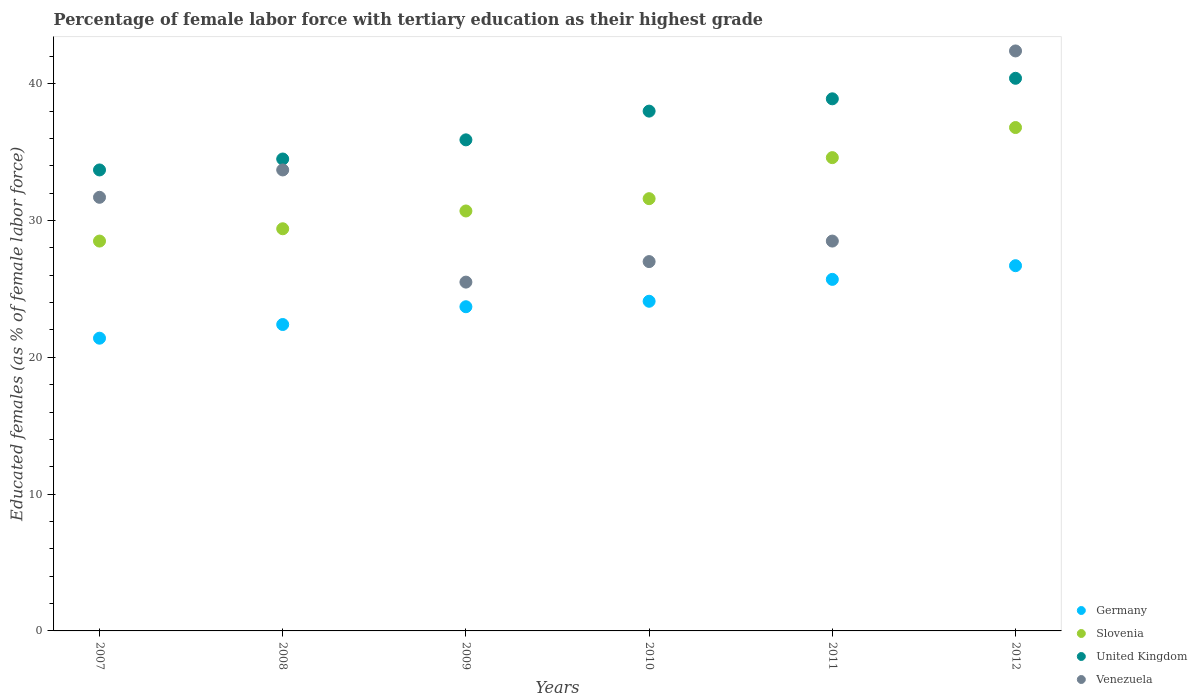Across all years, what is the maximum percentage of female labor force with tertiary education in United Kingdom?
Provide a short and direct response. 40.4. Across all years, what is the minimum percentage of female labor force with tertiary education in Germany?
Offer a terse response. 21.4. In which year was the percentage of female labor force with tertiary education in Germany maximum?
Give a very brief answer. 2012. In which year was the percentage of female labor force with tertiary education in Germany minimum?
Keep it short and to the point. 2007. What is the total percentage of female labor force with tertiary education in Venezuela in the graph?
Your response must be concise. 188.8. What is the difference between the percentage of female labor force with tertiary education in Venezuela in 2007 and that in 2012?
Give a very brief answer. -10.7. What is the difference between the percentage of female labor force with tertiary education in Germany in 2011 and the percentage of female labor force with tertiary education in Venezuela in 2010?
Give a very brief answer. -1.3. What is the average percentage of female labor force with tertiary education in United Kingdom per year?
Provide a short and direct response. 36.9. In how many years, is the percentage of female labor force with tertiary education in Slovenia greater than 10 %?
Your answer should be compact. 6. What is the ratio of the percentage of female labor force with tertiary education in Slovenia in 2007 to that in 2008?
Keep it short and to the point. 0.97. What is the difference between the highest and the lowest percentage of female labor force with tertiary education in Slovenia?
Your response must be concise. 8.3. Is it the case that in every year, the sum of the percentage of female labor force with tertiary education in United Kingdom and percentage of female labor force with tertiary education in Slovenia  is greater than the sum of percentage of female labor force with tertiary education in Venezuela and percentage of female labor force with tertiary education in Germany?
Provide a short and direct response. Yes. Is it the case that in every year, the sum of the percentage of female labor force with tertiary education in Germany and percentage of female labor force with tertiary education in Venezuela  is greater than the percentage of female labor force with tertiary education in United Kingdom?
Give a very brief answer. Yes. Does the percentage of female labor force with tertiary education in Germany monotonically increase over the years?
Your response must be concise. Yes. Is the percentage of female labor force with tertiary education in Venezuela strictly less than the percentage of female labor force with tertiary education in United Kingdom over the years?
Your response must be concise. No. How many dotlines are there?
Provide a succinct answer. 4. How many years are there in the graph?
Ensure brevity in your answer.  6. Does the graph contain any zero values?
Give a very brief answer. No. How many legend labels are there?
Make the answer very short. 4. How are the legend labels stacked?
Make the answer very short. Vertical. What is the title of the graph?
Your answer should be very brief. Percentage of female labor force with tertiary education as their highest grade. What is the label or title of the Y-axis?
Ensure brevity in your answer.  Educated females (as % of female labor force). What is the Educated females (as % of female labor force) of Germany in 2007?
Provide a succinct answer. 21.4. What is the Educated females (as % of female labor force) of United Kingdom in 2007?
Keep it short and to the point. 33.7. What is the Educated females (as % of female labor force) of Venezuela in 2007?
Ensure brevity in your answer.  31.7. What is the Educated females (as % of female labor force) in Germany in 2008?
Offer a terse response. 22.4. What is the Educated females (as % of female labor force) of Slovenia in 2008?
Keep it short and to the point. 29.4. What is the Educated females (as % of female labor force) in United Kingdom in 2008?
Keep it short and to the point. 34.5. What is the Educated females (as % of female labor force) of Venezuela in 2008?
Give a very brief answer. 33.7. What is the Educated females (as % of female labor force) of Germany in 2009?
Offer a terse response. 23.7. What is the Educated females (as % of female labor force) of Slovenia in 2009?
Provide a short and direct response. 30.7. What is the Educated females (as % of female labor force) in United Kingdom in 2009?
Ensure brevity in your answer.  35.9. What is the Educated females (as % of female labor force) in Venezuela in 2009?
Give a very brief answer. 25.5. What is the Educated females (as % of female labor force) of Germany in 2010?
Keep it short and to the point. 24.1. What is the Educated females (as % of female labor force) in Slovenia in 2010?
Keep it short and to the point. 31.6. What is the Educated females (as % of female labor force) of Venezuela in 2010?
Your answer should be very brief. 27. What is the Educated females (as % of female labor force) in Germany in 2011?
Provide a short and direct response. 25.7. What is the Educated females (as % of female labor force) in Slovenia in 2011?
Ensure brevity in your answer.  34.6. What is the Educated females (as % of female labor force) in United Kingdom in 2011?
Keep it short and to the point. 38.9. What is the Educated females (as % of female labor force) in Germany in 2012?
Offer a terse response. 26.7. What is the Educated females (as % of female labor force) of Slovenia in 2012?
Offer a very short reply. 36.8. What is the Educated females (as % of female labor force) in United Kingdom in 2012?
Offer a terse response. 40.4. What is the Educated females (as % of female labor force) of Venezuela in 2012?
Your answer should be compact. 42.4. Across all years, what is the maximum Educated females (as % of female labor force) of Germany?
Your response must be concise. 26.7. Across all years, what is the maximum Educated females (as % of female labor force) of Slovenia?
Ensure brevity in your answer.  36.8. Across all years, what is the maximum Educated females (as % of female labor force) in United Kingdom?
Provide a succinct answer. 40.4. Across all years, what is the maximum Educated females (as % of female labor force) in Venezuela?
Your response must be concise. 42.4. Across all years, what is the minimum Educated females (as % of female labor force) in Germany?
Your response must be concise. 21.4. Across all years, what is the minimum Educated females (as % of female labor force) of Slovenia?
Make the answer very short. 28.5. Across all years, what is the minimum Educated females (as % of female labor force) of United Kingdom?
Give a very brief answer. 33.7. What is the total Educated females (as % of female labor force) of Germany in the graph?
Provide a short and direct response. 144. What is the total Educated females (as % of female labor force) in Slovenia in the graph?
Keep it short and to the point. 191.6. What is the total Educated females (as % of female labor force) of United Kingdom in the graph?
Keep it short and to the point. 221.4. What is the total Educated females (as % of female labor force) of Venezuela in the graph?
Your response must be concise. 188.8. What is the difference between the Educated females (as % of female labor force) in Slovenia in 2007 and that in 2008?
Your response must be concise. -0.9. What is the difference between the Educated females (as % of female labor force) of United Kingdom in 2007 and that in 2008?
Ensure brevity in your answer.  -0.8. What is the difference between the Educated females (as % of female labor force) in Germany in 2007 and that in 2009?
Make the answer very short. -2.3. What is the difference between the Educated females (as % of female labor force) in Slovenia in 2007 and that in 2009?
Make the answer very short. -2.2. What is the difference between the Educated females (as % of female labor force) in United Kingdom in 2007 and that in 2009?
Give a very brief answer. -2.2. What is the difference between the Educated females (as % of female labor force) of Venezuela in 2007 and that in 2009?
Make the answer very short. 6.2. What is the difference between the Educated females (as % of female labor force) of Slovenia in 2007 and that in 2010?
Ensure brevity in your answer.  -3.1. What is the difference between the Educated females (as % of female labor force) in Germany in 2007 and that in 2011?
Your answer should be compact. -4.3. What is the difference between the Educated females (as % of female labor force) of Germany in 2007 and that in 2012?
Offer a terse response. -5.3. What is the difference between the Educated females (as % of female labor force) in Venezuela in 2007 and that in 2012?
Your answer should be compact. -10.7. What is the difference between the Educated females (as % of female labor force) in Venezuela in 2008 and that in 2009?
Provide a succinct answer. 8.2. What is the difference between the Educated females (as % of female labor force) in Germany in 2008 and that in 2010?
Your answer should be very brief. -1.7. What is the difference between the Educated females (as % of female labor force) in Slovenia in 2008 and that in 2010?
Your answer should be compact. -2.2. What is the difference between the Educated females (as % of female labor force) of Slovenia in 2008 and that in 2011?
Your answer should be very brief. -5.2. What is the difference between the Educated females (as % of female labor force) of Venezuela in 2008 and that in 2011?
Your answer should be very brief. 5.2. What is the difference between the Educated females (as % of female labor force) of Germany in 2008 and that in 2012?
Your response must be concise. -4.3. What is the difference between the Educated females (as % of female labor force) of Venezuela in 2008 and that in 2012?
Provide a succinct answer. -8.7. What is the difference between the Educated females (as % of female labor force) in Venezuela in 2009 and that in 2011?
Your answer should be compact. -3. What is the difference between the Educated females (as % of female labor force) of Slovenia in 2009 and that in 2012?
Your answer should be compact. -6.1. What is the difference between the Educated females (as % of female labor force) of Venezuela in 2009 and that in 2012?
Ensure brevity in your answer.  -16.9. What is the difference between the Educated females (as % of female labor force) of United Kingdom in 2010 and that in 2011?
Your response must be concise. -0.9. What is the difference between the Educated females (as % of female labor force) of Germany in 2010 and that in 2012?
Ensure brevity in your answer.  -2.6. What is the difference between the Educated females (as % of female labor force) of United Kingdom in 2010 and that in 2012?
Provide a succinct answer. -2.4. What is the difference between the Educated females (as % of female labor force) of Venezuela in 2010 and that in 2012?
Provide a short and direct response. -15.4. What is the difference between the Educated females (as % of female labor force) in United Kingdom in 2011 and that in 2012?
Your answer should be very brief. -1.5. What is the difference between the Educated females (as % of female labor force) in Germany in 2007 and the Educated females (as % of female labor force) in United Kingdom in 2008?
Ensure brevity in your answer.  -13.1. What is the difference between the Educated females (as % of female labor force) of Slovenia in 2007 and the Educated females (as % of female labor force) of United Kingdom in 2008?
Your response must be concise. -6. What is the difference between the Educated females (as % of female labor force) of Germany in 2007 and the Educated females (as % of female labor force) of Venezuela in 2009?
Provide a succinct answer. -4.1. What is the difference between the Educated females (as % of female labor force) of Slovenia in 2007 and the Educated females (as % of female labor force) of United Kingdom in 2009?
Provide a short and direct response. -7.4. What is the difference between the Educated females (as % of female labor force) of Germany in 2007 and the Educated females (as % of female labor force) of Slovenia in 2010?
Ensure brevity in your answer.  -10.2. What is the difference between the Educated females (as % of female labor force) in Germany in 2007 and the Educated females (as % of female labor force) in United Kingdom in 2010?
Make the answer very short. -16.6. What is the difference between the Educated females (as % of female labor force) in Germany in 2007 and the Educated females (as % of female labor force) in Venezuela in 2010?
Provide a succinct answer. -5.6. What is the difference between the Educated females (as % of female labor force) in Slovenia in 2007 and the Educated females (as % of female labor force) in United Kingdom in 2010?
Give a very brief answer. -9.5. What is the difference between the Educated females (as % of female labor force) of Slovenia in 2007 and the Educated females (as % of female labor force) of Venezuela in 2010?
Your response must be concise. 1.5. What is the difference between the Educated females (as % of female labor force) of Germany in 2007 and the Educated females (as % of female labor force) of Slovenia in 2011?
Provide a short and direct response. -13.2. What is the difference between the Educated females (as % of female labor force) in Germany in 2007 and the Educated females (as % of female labor force) in United Kingdom in 2011?
Provide a short and direct response. -17.5. What is the difference between the Educated females (as % of female labor force) of Germany in 2007 and the Educated females (as % of female labor force) of Venezuela in 2011?
Provide a succinct answer. -7.1. What is the difference between the Educated females (as % of female labor force) of United Kingdom in 2007 and the Educated females (as % of female labor force) of Venezuela in 2011?
Give a very brief answer. 5.2. What is the difference between the Educated females (as % of female labor force) of Germany in 2007 and the Educated females (as % of female labor force) of Slovenia in 2012?
Your answer should be very brief. -15.4. What is the difference between the Educated females (as % of female labor force) in Slovenia in 2007 and the Educated females (as % of female labor force) in United Kingdom in 2012?
Keep it short and to the point. -11.9. What is the difference between the Educated females (as % of female labor force) in Slovenia in 2007 and the Educated females (as % of female labor force) in Venezuela in 2012?
Make the answer very short. -13.9. What is the difference between the Educated females (as % of female labor force) in Germany in 2008 and the Educated females (as % of female labor force) in Slovenia in 2009?
Offer a terse response. -8.3. What is the difference between the Educated females (as % of female labor force) in Germany in 2008 and the Educated females (as % of female labor force) in Venezuela in 2009?
Ensure brevity in your answer.  -3.1. What is the difference between the Educated females (as % of female labor force) in Slovenia in 2008 and the Educated females (as % of female labor force) in Venezuela in 2009?
Provide a short and direct response. 3.9. What is the difference between the Educated females (as % of female labor force) in Germany in 2008 and the Educated females (as % of female labor force) in United Kingdom in 2010?
Make the answer very short. -15.6. What is the difference between the Educated females (as % of female labor force) in Slovenia in 2008 and the Educated females (as % of female labor force) in United Kingdom in 2010?
Your response must be concise. -8.6. What is the difference between the Educated females (as % of female labor force) in United Kingdom in 2008 and the Educated females (as % of female labor force) in Venezuela in 2010?
Keep it short and to the point. 7.5. What is the difference between the Educated females (as % of female labor force) of Germany in 2008 and the Educated females (as % of female labor force) of United Kingdom in 2011?
Your answer should be compact. -16.5. What is the difference between the Educated females (as % of female labor force) of Germany in 2008 and the Educated females (as % of female labor force) of Venezuela in 2011?
Offer a very short reply. -6.1. What is the difference between the Educated females (as % of female labor force) of Slovenia in 2008 and the Educated females (as % of female labor force) of United Kingdom in 2011?
Give a very brief answer. -9.5. What is the difference between the Educated females (as % of female labor force) in Slovenia in 2008 and the Educated females (as % of female labor force) in Venezuela in 2011?
Offer a very short reply. 0.9. What is the difference between the Educated females (as % of female labor force) of United Kingdom in 2008 and the Educated females (as % of female labor force) of Venezuela in 2011?
Provide a succinct answer. 6. What is the difference between the Educated females (as % of female labor force) in Germany in 2008 and the Educated females (as % of female labor force) in Slovenia in 2012?
Give a very brief answer. -14.4. What is the difference between the Educated females (as % of female labor force) in Germany in 2008 and the Educated females (as % of female labor force) in Venezuela in 2012?
Give a very brief answer. -20. What is the difference between the Educated females (as % of female labor force) in Slovenia in 2008 and the Educated females (as % of female labor force) in United Kingdom in 2012?
Provide a succinct answer. -11. What is the difference between the Educated females (as % of female labor force) of Slovenia in 2008 and the Educated females (as % of female labor force) of Venezuela in 2012?
Provide a succinct answer. -13. What is the difference between the Educated females (as % of female labor force) of Germany in 2009 and the Educated females (as % of female labor force) of United Kingdom in 2010?
Your answer should be very brief. -14.3. What is the difference between the Educated females (as % of female labor force) of Germany in 2009 and the Educated females (as % of female labor force) of Venezuela in 2010?
Ensure brevity in your answer.  -3.3. What is the difference between the Educated females (as % of female labor force) of Slovenia in 2009 and the Educated females (as % of female labor force) of United Kingdom in 2010?
Make the answer very short. -7.3. What is the difference between the Educated females (as % of female labor force) in United Kingdom in 2009 and the Educated females (as % of female labor force) in Venezuela in 2010?
Your answer should be very brief. 8.9. What is the difference between the Educated females (as % of female labor force) in Germany in 2009 and the Educated females (as % of female labor force) in United Kingdom in 2011?
Provide a short and direct response. -15.2. What is the difference between the Educated females (as % of female labor force) of Germany in 2009 and the Educated females (as % of female labor force) of Venezuela in 2011?
Your answer should be very brief. -4.8. What is the difference between the Educated females (as % of female labor force) in Slovenia in 2009 and the Educated females (as % of female labor force) in United Kingdom in 2011?
Your response must be concise. -8.2. What is the difference between the Educated females (as % of female labor force) in Slovenia in 2009 and the Educated females (as % of female labor force) in Venezuela in 2011?
Ensure brevity in your answer.  2.2. What is the difference between the Educated females (as % of female labor force) of United Kingdom in 2009 and the Educated females (as % of female labor force) of Venezuela in 2011?
Provide a succinct answer. 7.4. What is the difference between the Educated females (as % of female labor force) of Germany in 2009 and the Educated females (as % of female labor force) of Slovenia in 2012?
Your answer should be very brief. -13.1. What is the difference between the Educated females (as % of female labor force) of Germany in 2009 and the Educated females (as % of female labor force) of United Kingdom in 2012?
Offer a terse response. -16.7. What is the difference between the Educated females (as % of female labor force) of Germany in 2009 and the Educated females (as % of female labor force) of Venezuela in 2012?
Ensure brevity in your answer.  -18.7. What is the difference between the Educated females (as % of female labor force) in United Kingdom in 2009 and the Educated females (as % of female labor force) in Venezuela in 2012?
Give a very brief answer. -6.5. What is the difference between the Educated females (as % of female labor force) of Germany in 2010 and the Educated females (as % of female labor force) of United Kingdom in 2011?
Provide a short and direct response. -14.8. What is the difference between the Educated females (as % of female labor force) in Germany in 2010 and the Educated females (as % of female labor force) in Venezuela in 2011?
Your response must be concise. -4.4. What is the difference between the Educated females (as % of female labor force) of United Kingdom in 2010 and the Educated females (as % of female labor force) of Venezuela in 2011?
Keep it short and to the point. 9.5. What is the difference between the Educated females (as % of female labor force) of Germany in 2010 and the Educated females (as % of female labor force) of Slovenia in 2012?
Make the answer very short. -12.7. What is the difference between the Educated females (as % of female labor force) of Germany in 2010 and the Educated females (as % of female labor force) of United Kingdom in 2012?
Offer a terse response. -16.3. What is the difference between the Educated females (as % of female labor force) in Germany in 2010 and the Educated females (as % of female labor force) in Venezuela in 2012?
Provide a succinct answer. -18.3. What is the difference between the Educated females (as % of female labor force) of Slovenia in 2010 and the Educated females (as % of female labor force) of United Kingdom in 2012?
Give a very brief answer. -8.8. What is the difference between the Educated females (as % of female labor force) in United Kingdom in 2010 and the Educated females (as % of female labor force) in Venezuela in 2012?
Provide a succinct answer. -4.4. What is the difference between the Educated females (as % of female labor force) in Germany in 2011 and the Educated females (as % of female labor force) in Slovenia in 2012?
Your answer should be compact. -11.1. What is the difference between the Educated females (as % of female labor force) in Germany in 2011 and the Educated females (as % of female labor force) in United Kingdom in 2012?
Provide a succinct answer. -14.7. What is the difference between the Educated females (as % of female labor force) in Germany in 2011 and the Educated females (as % of female labor force) in Venezuela in 2012?
Your response must be concise. -16.7. What is the difference between the Educated females (as % of female labor force) of Slovenia in 2011 and the Educated females (as % of female labor force) of Venezuela in 2012?
Keep it short and to the point. -7.8. What is the difference between the Educated females (as % of female labor force) in United Kingdom in 2011 and the Educated females (as % of female labor force) in Venezuela in 2012?
Your answer should be very brief. -3.5. What is the average Educated females (as % of female labor force) of Slovenia per year?
Offer a very short reply. 31.93. What is the average Educated females (as % of female labor force) in United Kingdom per year?
Provide a short and direct response. 36.9. What is the average Educated females (as % of female labor force) of Venezuela per year?
Your answer should be compact. 31.47. In the year 2007, what is the difference between the Educated females (as % of female labor force) in Germany and Educated females (as % of female labor force) in Slovenia?
Give a very brief answer. -7.1. In the year 2007, what is the difference between the Educated females (as % of female labor force) in Germany and Educated females (as % of female labor force) in United Kingdom?
Keep it short and to the point. -12.3. In the year 2007, what is the difference between the Educated females (as % of female labor force) in Slovenia and Educated females (as % of female labor force) in United Kingdom?
Offer a very short reply. -5.2. In the year 2007, what is the difference between the Educated females (as % of female labor force) in Slovenia and Educated females (as % of female labor force) in Venezuela?
Your answer should be compact. -3.2. In the year 2007, what is the difference between the Educated females (as % of female labor force) of United Kingdom and Educated females (as % of female labor force) of Venezuela?
Make the answer very short. 2. In the year 2008, what is the difference between the Educated females (as % of female labor force) of Slovenia and Educated females (as % of female labor force) of Venezuela?
Make the answer very short. -4.3. In the year 2009, what is the difference between the Educated females (as % of female labor force) of Germany and Educated females (as % of female labor force) of United Kingdom?
Make the answer very short. -12.2. In the year 2009, what is the difference between the Educated females (as % of female labor force) of Slovenia and Educated females (as % of female labor force) of Venezuela?
Ensure brevity in your answer.  5.2. In the year 2010, what is the difference between the Educated females (as % of female labor force) of Slovenia and Educated females (as % of female labor force) of United Kingdom?
Make the answer very short. -6.4. In the year 2010, what is the difference between the Educated females (as % of female labor force) in United Kingdom and Educated females (as % of female labor force) in Venezuela?
Your answer should be very brief. 11. In the year 2011, what is the difference between the Educated females (as % of female labor force) of Germany and Educated females (as % of female labor force) of United Kingdom?
Your answer should be very brief. -13.2. In the year 2011, what is the difference between the Educated females (as % of female labor force) of Germany and Educated females (as % of female labor force) of Venezuela?
Ensure brevity in your answer.  -2.8. In the year 2011, what is the difference between the Educated females (as % of female labor force) of Slovenia and Educated females (as % of female labor force) of United Kingdom?
Keep it short and to the point. -4.3. In the year 2012, what is the difference between the Educated females (as % of female labor force) of Germany and Educated females (as % of female labor force) of Slovenia?
Offer a terse response. -10.1. In the year 2012, what is the difference between the Educated females (as % of female labor force) in Germany and Educated females (as % of female labor force) in United Kingdom?
Ensure brevity in your answer.  -13.7. In the year 2012, what is the difference between the Educated females (as % of female labor force) in Germany and Educated females (as % of female labor force) in Venezuela?
Make the answer very short. -15.7. In the year 2012, what is the difference between the Educated females (as % of female labor force) in Slovenia and Educated females (as % of female labor force) in United Kingdom?
Offer a very short reply. -3.6. In the year 2012, what is the difference between the Educated females (as % of female labor force) of Slovenia and Educated females (as % of female labor force) of Venezuela?
Your answer should be compact. -5.6. In the year 2012, what is the difference between the Educated females (as % of female labor force) of United Kingdom and Educated females (as % of female labor force) of Venezuela?
Provide a succinct answer. -2. What is the ratio of the Educated females (as % of female labor force) in Germany in 2007 to that in 2008?
Ensure brevity in your answer.  0.96. What is the ratio of the Educated females (as % of female labor force) in Slovenia in 2007 to that in 2008?
Provide a short and direct response. 0.97. What is the ratio of the Educated females (as % of female labor force) in United Kingdom in 2007 to that in 2008?
Offer a very short reply. 0.98. What is the ratio of the Educated females (as % of female labor force) of Venezuela in 2007 to that in 2008?
Your answer should be compact. 0.94. What is the ratio of the Educated females (as % of female labor force) of Germany in 2007 to that in 2009?
Keep it short and to the point. 0.9. What is the ratio of the Educated females (as % of female labor force) in Slovenia in 2007 to that in 2009?
Make the answer very short. 0.93. What is the ratio of the Educated females (as % of female labor force) of United Kingdom in 2007 to that in 2009?
Your response must be concise. 0.94. What is the ratio of the Educated females (as % of female labor force) in Venezuela in 2007 to that in 2009?
Give a very brief answer. 1.24. What is the ratio of the Educated females (as % of female labor force) in Germany in 2007 to that in 2010?
Keep it short and to the point. 0.89. What is the ratio of the Educated females (as % of female labor force) of Slovenia in 2007 to that in 2010?
Your answer should be very brief. 0.9. What is the ratio of the Educated females (as % of female labor force) in United Kingdom in 2007 to that in 2010?
Your answer should be very brief. 0.89. What is the ratio of the Educated females (as % of female labor force) in Venezuela in 2007 to that in 2010?
Offer a very short reply. 1.17. What is the ratio of the Educated females (as % of female labor force) in Germany in 2007 to that in 2011?
Your answer should be compact. 0.83. What is the ratio of the Educated females (as % of female labor force) of Slovenia in 2007 to that in 2011?
Give a very brief answer. 0.82. What is the ratio of the Educated females (as % of female labor force) of United Kingdom in 2007 to that in 2011?
Offer a very short reply. 0.87. What is the ratio of the Educated females (as % of female labor force) of Venezuela in 2007 to that in 2011?
Your answer should be compact. 1.11. What is the ratio of the Educated females (as % of female labor force) of Germany in 2007 to that in 2012?
Your response must be concise. 0.8. What is the ratio of the Educated females (as % of female labor force) of Slovenia in 2007 to that in 2012?
Provide a short and direct response. 0.77. What is the ratio of the Educated females (as % of female labor force) of United Kingdom in 2007 to that in 2012?
Offer a terse response. 0.83. What is the ratio of the Educated females (as % of female labor force) of Venezuela in 2007 to that in 2012?
Your answer should be very brief. 0.75. What is the ratio of the Educated females (as % of female labor force) of Germany in 2008 to that in 2009?
Provide a short and direct response. 0.95. What is the ratio of the Educated females (as % of female labor force) in Slovenia in 2008 to that in 2009?
Provide a succinct answer. 0.96. What is the ratio of the Educated females (as % of female labor force) in Venezuela in 2008 to that in 2009?
Ensure brevity in your answer.  1.32. What is the ratio of the Educated females (as % of female labor force) of Germany in 2008 to that in 2010?
Your answer should be very brief. 0.93. What is the ratio of the Educated females (as % of female labor force) of Slovenia in 2008 to that in 2010?
Provide a succinct answer. 0.93. What is the ratio of the Educated females (as % of female labor force) of United Kingdom in 2008 to that in 2010?
Provide a succinct answer. 0.91. What is the ratio of the Educated females (as % of female labor force) of Venezuela in 2008 to that in 2010?
Provide a short and direct response. 1.25. What is the ratio of the Educated females (as % of female labor force) in Germany in 2008 to that in 2011?
Ensure brevity in your answer.  0.87. What is the ratio of the Educated females (as % of female labor force) in Slovenia in 2008 to that in 2011?
Your response must be concise. 0.85. What is the ratio of the Educated females (as % of female labor force) of United Kingdom in 2008 to that in 2011?
Keep it short and to the point. 0.89. What is the ratio of the Educated females (as % of female labor force) of Venezuela in 2008 to that in 2011?
Give a very brief answer. 1.18. What is the ratio of the Educated females (as % of female labor force) in Germany in 2008 to that in 2012?
Make the answer very short. 0.84. What is the ratio of the Educated females (as % of female labor force) in Slovenia in 2008 to that in 2012?
Give a very brief answer. 0.8. What is the ratio of the Educated females (as % of female labor force) of United Kingdom in 2008 to that in 2012?
Give a very brief answer. 0.85. What is the ratio of the Educated females (as % of female labor force) in Venezuela in 2008 to that in 2012?
Your answer should be compact. 0.79. What is the ratio of the Educated females (as % of female labor force) in Germany in 2009 to that in 2010?
Ensure brevity in your answer.  0.98. What is the ratio of the Educated females (as % of female labor force) of Slovenia in 2009 to that in 2010?
Provide a succinct answer. 0.97. What is the ratio of the Educated females (as % of female labor force) in United Kingdom in 2009 to that in 2010?
Your answer should be compact. 0.94. What is the ratio of the Educated females (as % of female labor force) of Germany in 2009 to that in 2011?
Your response must be concise. 0.92. What is the ratio of the Educated females (as % of female labor force) in Slovenia in 2009 to that in 2011?
Provide a short and direct response. 0.89. What is the ratio of the Educated females (as % of female labor force) of United Kingdom in 2009 to that in 2011?
Keep it short and to the point. 0.92. What is the ratio of the Educated females (as % of female labor force) in Venezuela in 2009 to that in 2011?
Your answer should be very brief. 0.89. What is the ratio of the Educated females (as % of female labor force) in Germany in 2009 to that in 2012?
Provide a short and direct response. 0.89. What is the ratio of the Educated females (as % of female labor force) of Slovenia in 2009 to that in 2012?
Your answer should be very brief. 0.83. What is the ratio of the Educated females (as % of female labor force) in United Kingdom in 2009 to that in 2012?
Make the answer very short. 0.89. What is the ratio of the Educated females (as % of female labor force) of Venezuela in 2009 to that in 2012?
Your response must be concise. 0.6. What is the ratio of the Educated females (as % of female labor force) of Germany in 2010 to that in 2011?
Your answer should be compact. 0.94. What is the ratio of the Educated females (as % of female labor force) in Slovenia in 2010 to that in 2011?
Offer a terse response. 0.91. What is the ratio of the Educated females (as % of female labor force) in United Kingdom in 2010 to that in 2011?
Provide a succinct answer. 0.98. What is the ratio of the Educated females (as % of female labor force) in Venezuela in 2010 to that in 2011?
Your answer should be compact. 0.95. What is the ratio of the Educated females (as % of female labor force) in Germany in 2010 to that in 2012?
Give a very brief answer. 0.9. What is the ratio of the Educated females (as % of female labor force) of Slovenia in 2010 to that in 2012?
Give a very brief answer. 0.86. What is the ratio of the Educated females (as % of female labor force) of United Kingdom in 2010 to that in 2012?
Offer a terse response. 0.94. What is the ratio of the Educated females (as % of female labor force) in Venezuela in 2010 to that in 2012?
Make the answer very short. 0.64. What is the ratio of the Educated females (as % of female labor force) in Germany in 2011 to that in 2012?
Make the answer very short. 0.96. What is the ratio of the Educated females (as % of female labor force) of Slovenia in 2011 to that in 2012?
Keep it short and to the point. 0.94. What is the ratio of the Educated females (as % of female labor force) of United Kingdom in 2011 to that in 2012?
Ensure brevity in your answer.  0.96. What is the ratio of the Educated females (as % of female labor force) in Venezuela in 2011 to that in 2012?
Provide a succinct answer. 0.67. What is the difference between the highest and the second highest Educated females (as % of female labor force) in Slovenia?
Your response must be concise. 2.2. What is the difference between the highest and the lowest Educated females (as % of female labor force) of Germany?
Keep it short and to the point. 5.3. 